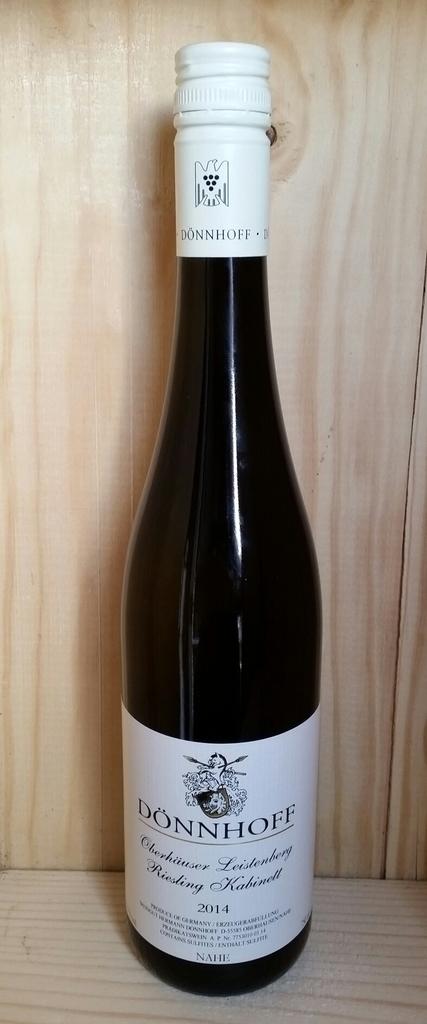What kind of wine is this?
Your answer should be compact. Donnhoff. What is the year of the wine?
Your answer should be very brief. 2014. 